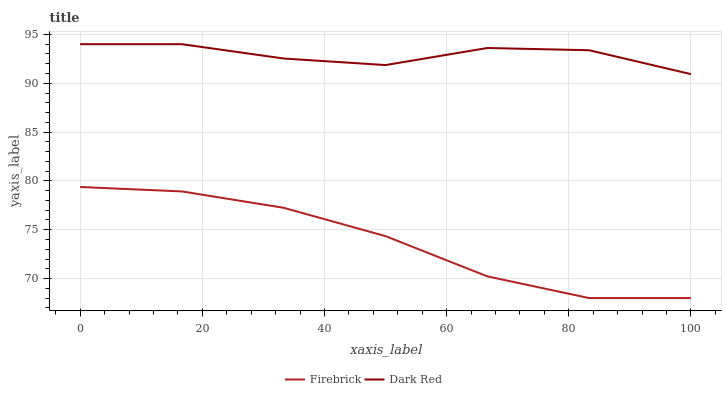Does Firebrick have the minimum area under the curve?
Answer yes or no. Yes. Does Dark Red have the maximum area under the curve?
Answer yes or no. Yes. Does Firebrick have the maximum area under the curve?
Answer yes or no. No. Is Firebrick the smoothest?
Answer yes or no. Yes. Is Dark Red the roughest?
Answer yes or no. Yes. Is Firebrick the roughest?
Answer yes or no. No. Does Firebrick have the lowest value?
Answer yes or no. Yes. Does Dark Red have the highest value?
Answer yes or no. Yes. Does Firebrick have the highest value?
Answer yes or no. No. Is Firebrick less than Dark Red?
Answer yes or no. Yes. Is Dark Red greater than Firebrick?
Answer yes or no. Yes. Does Firebrick intersect Dark Red?
Answer yes or no. No. 